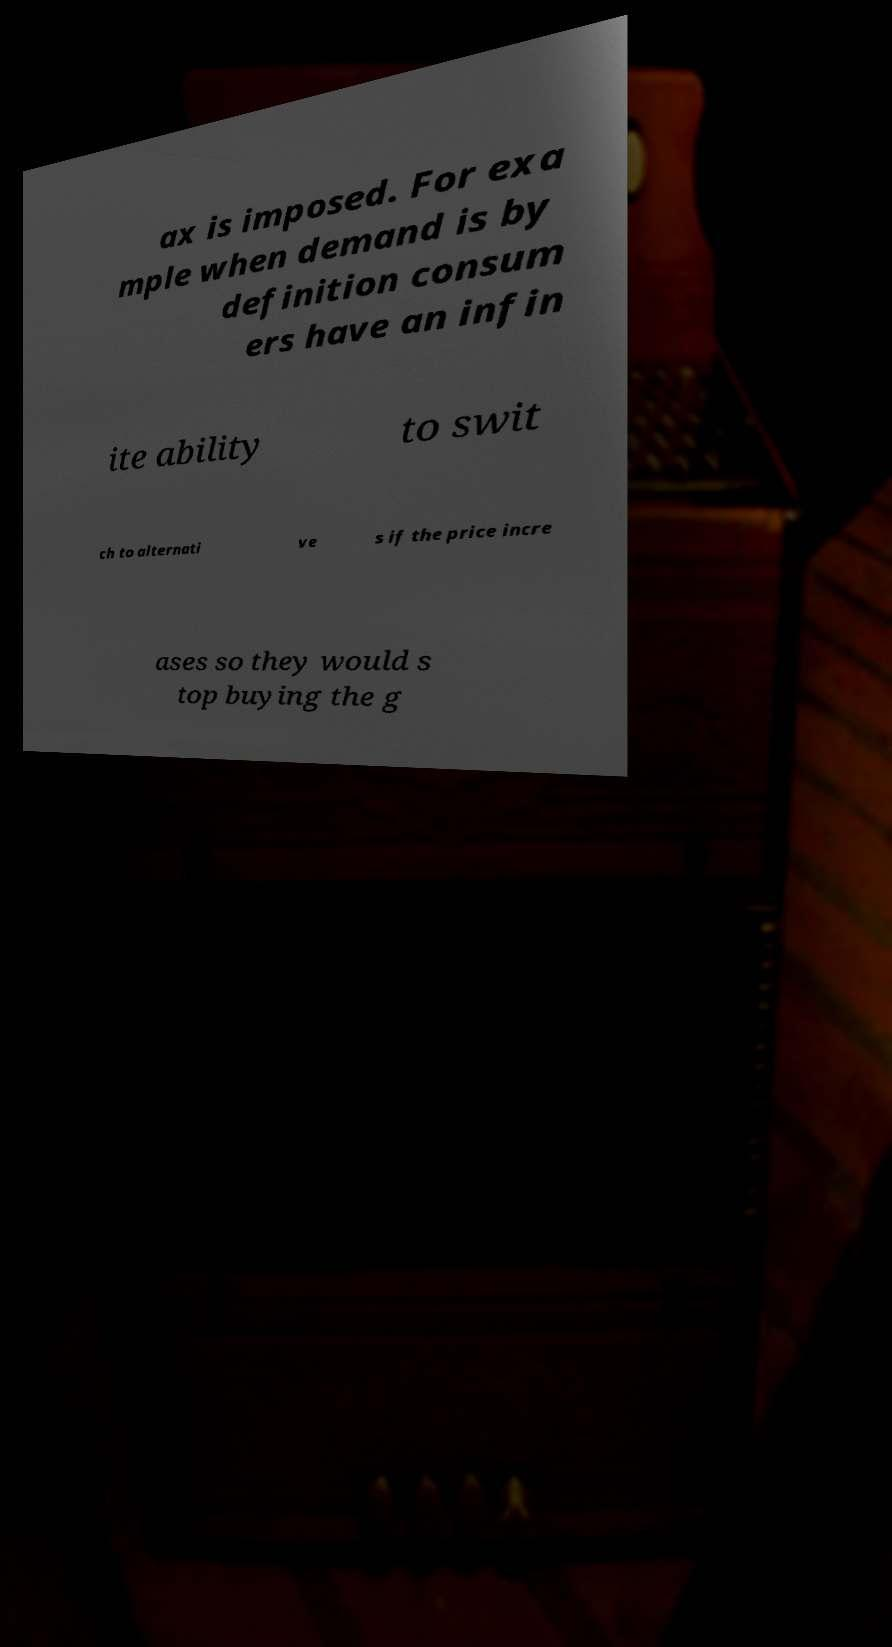I need the written content from this picture converted into text. Can you do that? ax is imposed. For exa mple when demand is by definition consum ers have an infin ite ability to swit ch to alternati ve s if the price incre ases so they would s top buying the g 